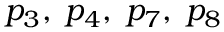Convert formula to latex. <formula><loc_0><loc_0><loc_500><loc_500>p _ { 3 } , \, p _ { 4 } , \, p _ { 7 } , \, p _ { 8 }</formula> 